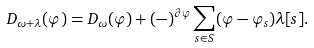<formula> <loc_0><loc_0><loc_500><loc_500>D _ { \omega + \lambda } ( \varphi ) = D _ { \omega } ( \varphi ) + ( - ) ^ { \partial \varphi } \sum _ { s \in S } ( \varphi - \varphi _ { s } ) \lambda [ s ] .</formula> 